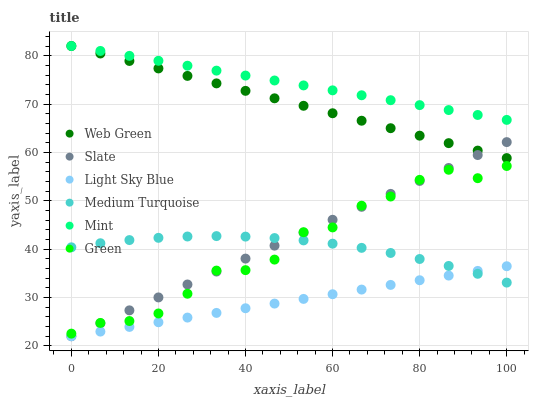Does Light Sky Blue have the minimum area under the curve?
Answer yes or no. Yes. Does Mint have the maximum area under the curve?
Answer yes or no. Yes. Does Web Green have the minimum area under the curve?
Answer yes or no. No. Does Web Green have the maximum area under the curve?
Answer yes or no. No. Is Light Sky Blue the smoothest?
Answer yes or no. Yes. Is Green the roughest?
Answer yes or no. Yes. Is Web Green the smoothest?
Answer yes or no. No. Is Web Green the roughest?
Answer yes or no. No. Does Slate have the lowest value?
Answer yes or no. Yes. Does Web Green have the lowest value?
Answer yes or no. No. Does Mint have the highest value?
Answer yes or no. Yes. Does Light Sky Blue have the highest value?
Answer yes or no. No. Is Light Sky Blue less than Web Green?
Answer yes or no. Yes. Is Mint greater than Light Sky Blue?
Answer yes or no. Yes. Does Slate intersect Light Sky Blue?
Answer yes or no. Yes. Is Slate less than Light Sky Blue?
Answer yes or no. No. Is Slate greater than Light Sky Blue?
Answer yes or no. No. Does Light Sky Blue intersect Web Green?
Answer yes or no. No. 